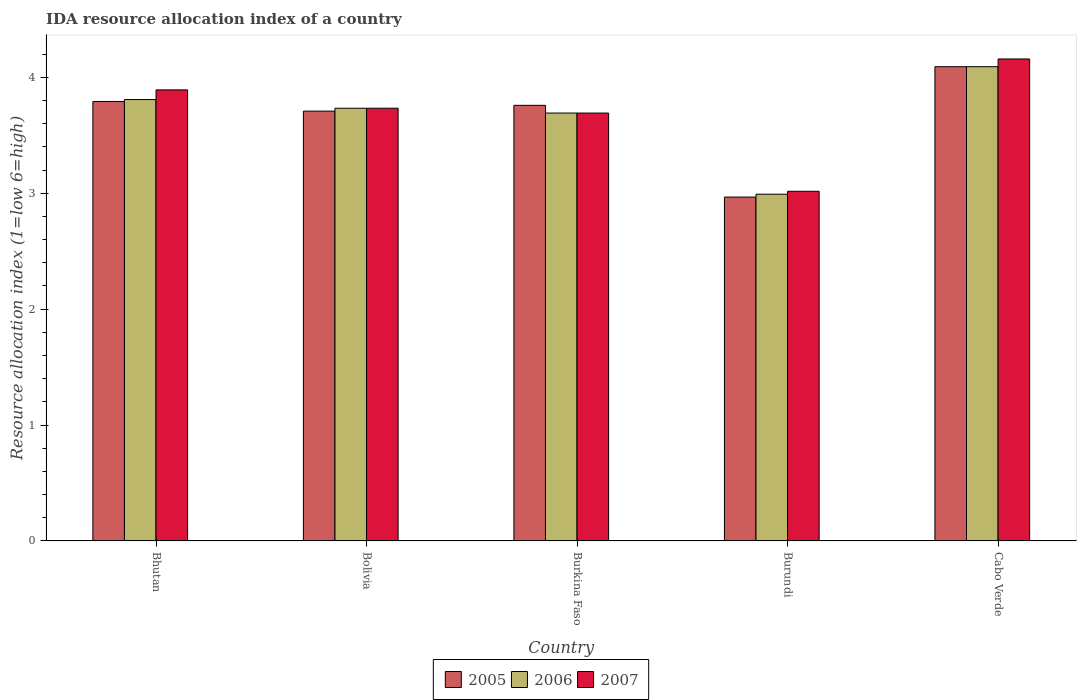How many groups of bars are there?
Provide a succinct answer. 5. Are the number of bars per tick equal to the number of legend labels?
Ensure brevity in your answer.  Yes. Are the number of bars on each tick of the X-axis equal?
Offer a terse response. Yes. How many bars are there on the 1st tick from the left?
Your response must be concise. 3. What is the label of the 1st group of bars from the left?
Your response must be concise. Bhutan. In how many cases, is the number of bars for a given country not equal to the number of legend labels?
Offer a very short reply. 0. What is the IDA resource allocation index in 2005 in Burundi?
Keep it short and to the point. 2.97. Across all countries, what is the maximum IDA resource allocation index in 2007?
Your response must be concise. 4.16. Across all countries, what is the minimum IDA resource allocation index in 2005?
Your answer should be very brief. 2.97. In which country was the IDA resource allocation index in 2006 maximum?
Your response must be concise. Cabo Verde. In which country was the IDA resource allocation index in 2005 minimum?
Offer a very short reply. Burundi. What is the total IDA resource allocation index in 2005 in the graph?
Your answer should be very brief. 18.32. What is the difference between the IDA resource allocation index in 2006 in Bhutan and that in Cabo Verde?
Offer a terse response. -0.28. What is the difference between the IDA resource allocation index in 2006 in Burkina Faso and the IDA resource allocation index in 2007 in Burundi?
Your response must be concise. 0.67. What is the average IDA resource allocation index in 2005 per country?
Offer a very short reply. 3.66. What is the difference between the IDA resource allocation index of/in 2007 and IDA resource allocation index of/in 2006 in Burkina Faso?
Provide a short and direct response. 0. In how many countries, is the IDA resource allocation index in 2007 greater than 3?
Keep it short and to the point. 5. What is the ratio of the IDA resource allocation index in 2005 in Burundi to that in Cabo Verde?
Give a very brief answer. 0.73. Is the difference between the IDA resource allocation index in 2007 in Bhutan and Burkina Faso greater than the difference between the IDA resource allocation index in 2006 in Bhutan and Burkina Faso?
Your answer should be very brief. Yes. What is the difference between the highest and the second highest IDA resource allocation index in 2006?
Keep it short and to the point. -0.08. What is the difference between the highest and the lowest IDA resource allocation index in 2005?
Ensure brevity in your answer.  1.12. In how many countries, is the IDA resource allocation index in 2007 greater than the average IDA resource allocation index in 2007 taken over all countries?
Ensure brevity in your answer.  3. Is the sum of the IDA resource allocation index in 2005 in Bhutan and Bolivia greater than the maximum IDA resource allocation index in 2006 across all countries?
Offer a terse response. Yes. What does the 3rd bar from the left in Burundi represents?
Keep it short and to the point. 2007. What does the 2nd bar from the right in Burundi represents?
Provide a succinct answer. 2006. Is it the case that in every country, the sum of the IDA resource allocation index in 2006 and IDA resource allocation index in 2005 is greater than the IDA resource allocation index in 2007?
Give a very brief answer. Yes. Are all the bars in the graph horizontal?
Provide a succinct answer. No. What is the difference between two consecutive major ticks on the Y-axis?
Your response must be concise. 1. Does the graph contain any zero values?
Make the answer very short. No. What is the title of the graph?
Provide a short and direct response. IDA resource allocation index of a country. Does "2012" appear as one of the legend labels in the graph?
Keep it short and to the point. No. What is the label or title of the Y-axis?
Offer a terse response. Resource allocation index (1=low 6=high). What is the Resource allocation index (1=low 6=high) of 2005 in Bhutan?
Provide a succinct answer. 3.79. What is the Resource allocation index (1=low 6=high) in 2006 in Bhutan?
Offer a very short reply. 3.81. What is the Resource allocation index (1=low 6=high) of 2007 in Bhutan?
Keep it short and to the point. 3.89. What is the Resource allocation index (1=low 6=high) of 2005 in Bolivia?
Provide a short and direct response. 3.71. What is the Resource allocation index (1=low 6=high) of 2006 in Bolivia?
Keep it short and to the point. 3.73. What is the Resource allocation index (1=low 6=high) in 2007 in Bolivia?
Your answer should be very brief. 3.73. What is the Resource allocation index (1=low 6=high) of 2005 in Burkina Faso?
Your answer should be very brief. 3.76. What is the Resource allocation index (1=low 6=high) in 2006 in Burkina Faso?
Offer a terse response. 3.69. What is the Resource allocation index (1=low 6=high) of 2007 in Burkina Faso?
Offer a terse response. 3.69. What is the Resource allocation index (1=low 6=high) of 2005 in Burundi?
Make the answer very short. 2.97. What is the Resource allocation index (1=low 6=high) of 2006 in Burundi?
Keep it short and to the point. 2.99. What is the Resource allocation index (1=low 6=high) of 2007 in Burundi?
Offer a very short reply. 3.02. What is the Resource allocation index (1=low 6=high) of 2005 in Cabo Verde?
Offer a terse response. 4.09. What is the Resource allocation index (1=low 6=high) in 2006 in Cabo Verde?
Your answer should be very brief. 4.09. What is the Resource allocation index (1=low 6=high) in 2007 in Cabo Verde?
Your answer should be compact. 4.16. Across all countries, what is the maximum Resource allocation index (1=low 6=high) of 2005?
Offer a terse response. 4.09. Across all countries, what is the maximum Resource allocation index (1=low 6=high) of 2006?
Ensure brevity in your answer.  4.09. Across all countries, what is the maximum Resource allocation index (1=low 6=high) in 2007?
Ensure brevity in your answer.  4.16. Across all countries, what is the minimum Resource allocation index (1=low 6=high) in 2005?
Make the answer very short. 2.97. Across all countries, what is the minimum Resource allocation index (1=low 6=high) in 2006?
Offer a very short reply. 2.99. Across all countries, what is the minimum Resource allocation index (1=low 6=high) of 2007?
Your response must be concise. 3.02. What is the total Resource allocation index (1=low 6=high) in 2005 in the graph?
Your answer should be very brief. 18.32. What is the total Resource allocation index (1=low 6=high) of 2006 in the graph?
Your response must be concise. 18.32. What is the total Resource allocation index (1=low 6=high) in 2007 in the graph?
Your answer should be compact. 18.49. What is the difference between the Resource allocation index (1=low 6=high) in 2005 in Bhutan and that in Bolivia?
Offer a very short reply. 0.08. What is the difference between the Resource allocation index (1=low 6=high) in 2006 in Bhutan and that in Bolivia?
Make the answer very short. 0.07. What is the difference between the Resource allocation index (1=low 6=high) of 2007 in Bhutan and that in Bolivia?
Make the answer very short. 0.16. What is the difference between the Resource allocation index (1=low 6=high) of 2006 in Bhutan and that in Burkina Faso?
Provide a short and direct response. 0.12. What is the difference between the Resource allocation index (1=low 6=high) of 2005 in Bhutan and that in Burundi?
Give a very brief answer. 0.82. What is the difference between the Resource allocation index (1=low 6=high) of 2006 in Bhutan and that in Burundi?
Keep it short and to the point. 0.82. What is the difference between the Resource allocation index (1=low 6=high) in 2007 in Bhutan and that in Burundi?
Ensure brevity in your answer.  0.88. What is the difference between the Resource allocation index (1=low 6=high) in 2005 in Bhutan and that in Cabo Verde?
Your answer should be very brief. -0.3. What is the difference between the Resource allocation index (1=low 6=high) in 2006 in Bhutan and that in Cabo Verde?
Give a very brief answer. -0.28. What is the difference between the Resource allocation index (1=low 6=high) in 2007 in Bhutan and that in Cabo Verde?
Offer a terse response. -0.27. What is the difference between the Resource allocation index (1=low 6=high) of 2006 in Bolivia and that in Burkina Faso?
Make the answer very short. 0.04. What is the difference between the Resource allocation index (1=low 6=high) of 2007 in Bolivia and that in Burkina Faso?
Make the answer very short. 0.04. What is the difference between the Resource allocation index (1=low 6=high) in 2005 in Bolivia and that in Burundi?
Ensure brevity in your answer.  0.74. What is the difference between the Resource allocation index (1=low 6=high) in 2006 in Bolivia and that in Burundi?
Offer a terse response. 0.74. What is the difference between the Resource allocation index (1=low 6=high) of 2007 in Bolivia and that in Burundi?
Offer a very short reply. 0.72. What is the difference between the Resource allocation index (1=low 6=high) in 2005 in Bolivia and that in Cabo Verde?
Ensure brevity in your answer.  -0.38. What is the difference between the Resource allocation index (1=low 6=high) in 2006 in Bolivia and that in Cabo Verde?
Keep it short and to the point. -0.36. What is the difference between the Resource allocation index (1=low 6=high) of 2007 in Bolivia and that in Cabo Verde?
Your response must be concise. -0.42. What is the difference between the Resource allocation index (1=low 6=high) of 2005 in Burkina Faso and that in Burundi?
Your answer should be very brief. 0.79. What is the difference between the Resource allocation index (1=low 6=high) of 2007 in Burkina Faso and that in Burundi?
Provide a succinct answer. 0.68. What is the difference between the Resource allocation index (1=low 6=high) in 2006 in Burkina Faso and that in Cabo Verde?
Your answer should be compact. -0.4. What is the difference between the Resource allocation index (1=low 6=high) in 2007 in Burkina Faso and that in Cabo Verde?
Keep it short and to the point. -0.47. What is the difference between the Resource allocation index (1=low 6=high) in 2005 in Burundi and that in Cabo Verde?
Provide a succinct answer. -1.12. What is the difference between the Resource allocation index (1=low 6=high) in 2006 in Burundi and that in Cabo Verde?
Offer a terse response. -1.1. What is the difference between the Resource allocation index (1=low 6=high) in 2007 in Burundi and that in Cabo Verde?
Your response must be concise. -1.14. What is the difference between the Resource allocation index (1=low 6=high) of 2005 in Bhutan and the Resource allocation index (1=low 6=high) of 2006 in Bolivia?
Ensure brevity in your answer.  0.06. What is the difference between the Resource allocation index (1=low 6=high) in 2005 in Bhutan and the Resource allocation index (1=low 6=high) in 2007 in Bolivia?
Provide a succinct answer. 0.06. What is the difference between the Resource allocation index (1=low 6=high) of 2006 in Bhutan and the Resource allocation index (1=low 6=high) of 2007 in Bolivia?
Offer a terse response. 0.07. What is the difference between the Resource allocation index (1=low 6=high) in 2005 in Bhutan and the Resource allocation index (1=low 6=high) in 2006 in Burkina Faso?
Make the answer very short. 0.1. What is the difference between the Resource allocation index (1=low 6=high) in 2005 in Bhutan and the Resource allocation index (1=low 6=high) in 2007 in Burkina Faso?
Offer a very short reply. 0.1. What is the difference between the Resource allocation index (1=low 6=high) in 2006 in Bhutan and the Resource allocation index (1=low 6=high) in 2007 in Burkina Faso?
Make the answer very short. 0.12. What is the difference between the Resource allocation index (1=low 6=high) in 2005 in Bhutan and the Resource allocation index (1=low 6=high) in 2006 in Burundi?
Your answer should be compact. 0.8. What is the difference between the Resource allocation index (1=low 6=high) in 2005 in Bhutan and the Resource allocation index (1=low 6=high) in 2007 in Burundi?
Provide a short and direct response. 0.78. What is the difference between the Resource allocation index (1=low 6=high) of 2006 in Bhutan and the Resource allocation index (1=low 6=high) of 2007 in Burundi?
Your response must be concise. 0.79. What is the difference between the Resource allocation index (1=low 6=high) in 2005 in Bhutan and the Resource allocation index (1=low 6=high) in 2007 in Cabo Verde?
Keep it short and to the point. -0.37. What is the difference between the Resource allocation index (1=low 6=high) in 2006 in Bhutan and the Resource allocation index (1=low 6=high) in 2007 in Cabo Verde?
Your answer should be very brief. -0.35. What is the difference between the Resource allocation index (1=low 6=high) of 2005 in Bolivia and the Resource allocation index (1=low 6=high) of 2006 in Burkina Faso?
Offer a very short reply. 0.02. What is the difference between the Resource allocation index (1=low 6=high) in 2005 in Bolivia and the Resource allocation index (1=low 6=high) in 2007 in Burkina Faso?
Offer a very short reply. 0.02. What is the difference between the Resource allocation index (1=low 6=high) of 2006 in Bolivia and the Resource allocation index (1=low 6=high) of 2007 in Burkina Faso?
Keep it short and to the point. 0.04. What is the difference between the Resource allocation index (1=low 6=high) of 2005 in Bolivia and the Resource allocation index (1=low 6=high) of 2006 in Burundi?
Offer a terse response. 0.72. What is the difference between the Resource allocation index (1=low 6=high) in 2005 in Bolivia and the Resource allocation index (1=low 6=high) in 2007 in Burundi?
Your response must be concise. 0.69. What is the difference between the Resource allocation index (1=low 6=high) of 2006 in Bolivia and the Resource allocation index (1=low 6=high) of 2007 in Burundi?
Give a very brief answer. 0.72. What is the difference between the Resource allocation index (1=low 6=high) of 2005 in Bolivia and the Resource allocation index (1=low 6=high) of 2006 in Cabo Verde?
Ensure brevity in your answer.  -0.38. What is the difference between the Resource allocation index (1=low 6=high) in 2005 in Bolivia and the Resource allocation index (1=low 6=high) in 2007 in Cabo Verde?
Give a very brief answer. -0.45. What is the difference between the Resource allocation index (1=low 6=high) in 2006 in Bolivia and the Resource allocation index (1=low 6=high) in 2007 in Cabo Verde?
Your answer should be compact. -0.42. What is the difference between the Resource allocation index (1=low 6=high) in 2005 in Burkina Faso and the Resource allocation index (1=low 6=high) in 2006 in Burundi?
Offer a very short reply. 0.77. What is the difference between the Resource allocation index (1=low 6=high) in 2005 in Burkina Faso and the Resource allocation index (1=low 6=high) in 2007 in Burundi?
Provide a succinct answer. 0.74. What is the difference between the Resource allocation index (1=low 6=high) in 2006 in Burkina Faso and the Resource allocation index (1=low 6=high) in 2007 in Burundi?
Keep it short and to the point. 0.68. What is the difference between the Resource allocation index (1=low 6=high) in 2005 in Burkina Faso and the Resource allocation index (1=low 6=high) in 2006 in Cabo Verde?
Offer a very short reply. -0.33. What is the difference between the Resource allocation index (1=low 6=high) in 2006 in Burkina Faso and the Resource allocation index (1=low 6=high) in 2007 in Cabo Verde?
Provide a succinct answer. -0.47. What is the difference between the Resource allocation index (1=low 6=high) in 2005 in Burundi and the Resource allocation index (1=low 6=high) in 2006 in Cabo Verde?
Offer a terse response. -1.12. What is the difference between the Resource allocation index (1=low 6=high) in 2005 in Burundi and the Resource allocation index (1=low 6=high) in 2007 in Cabo Verde?
Give a very brief answer. -1.19. What is the difference between the Resource allocation index (1=low 6=high) in 2006 in Burundi and the Resource allocation index (1=low 6=high) in 2007 in Cabo Verde?
Your answer should be compact. -1.17. What is the average Resource allocation index (1=low 6=high) of 2005 per country?
Keep it short and to the point. 3.66. What is the average Resource allocation index (1=low 6=high) of 2006 per country?
Make the answer very short. 3.66. What is the average Resource allocation index (1=low 6=high) of 2007 per country?
Provide a short and direct response. 3.7. What is the difference between the Resource allocation index (1=low 6=high) of 2005 and Resource allocation index (1=low 6=high) of 2006 in Bhutan?
Offer a very short reply. -0.02. What is the difference between the Resource allocation index (1=low 6=high) in 2006 and Resource allocation index (1=low 6=high) in 2007 in Bhutan?
Keep it short and to the point. -0.08. What is the difference between the Resource allocation index (1=low 6=high) in 2005 and Resource allocation index (1=low 6=high) in 2006 in Bolivia?
Your response must be concise. -0.03. What is the difference between the Resource allocation index (1=low 6=high) in 2005 and Resource allocation index (1=low 6=high) in 2007 in Bolivia?
Offer a very short reply. -0.03. What is the difference between the Resource allocation index (1=low 6=high) of 2006 and Resource allocation index (1=low 6=high) of 2007 in Bolivia?
Your answer should be very brief. 0. What is the difference between the Resource allocation index (1=low 6=high) of 2005 and Resource allocation index (1=low 6=high) of 2006 in Burkina Faso?
Give a very brief answer. 0.07. What is the difference between the Resource allocation index (1=low 6=high) in 2005 and Resource allocation index (1=low 6=high) in 2007 in Burkina Faso?
Your answer should be compact. 0.07. What is the difference between the Resource allocation index (1=low 6=high) in 2006 and Resource allocation index (1=low 6=high) in 2007 in Burkina Faso?
Your response must be concise. 0. What is the difference between the Resource allocation index (1=low 6=high) of 2005 and Resource allocation index (1=low 6=high) of 2006 in Burundi?
Make the answer very short. -0.03. What is the difference between the Resource allocation index (1=low 6=high) in 2005 and Resource allocation index (1=low 6=high) in 2007 in Burundi?
Offer a very short reply. -0.05. What is the difference between the Resource allocation index (1=low 6=high) in 2006 and Resource allocation index (1=low 6=high) in 2007 in Burundi?
Offer a terse response. -0.03. What is the difference between the Resource allocation index (1=low 6=high) in 2005 and Resource allocation index (1=low 6=high) in 2006 in Cabo Verde?
Make the answer very short. 0. What is the difference between the Resource allocation index (1=low 6=high) of 2005 and Resource allocation index (1=low 6=high) of 2007 in Cabo Verde?
Make the answer very short. -0.07. What is the difference between the Resource allocation index (1=low 6=high) of 2006 and Resource allocation index (1=low 6=high) of 2007 in Cabo Verde?
Offer a terse response. -0.07. What is the ratio of the Resource allocation index (1=low 6=high) of 2005 in Bhutan to that in Bolivia?
Offer a terse response. 1.02. What is the ratio of the Resource allocation index (1=low 6=high) of 2006 in Bhutan to that in Bolivia?
Offer a very short reply. 1.02. What is the ratio of the Resource allocation index (1=low 6=high) of 2007 in Bhutan to that in Bolivia?
Your response must be concise. 1.04. What is the ratio of the Resource allocation index (1=low 6=high) of 2005 in Bhutan to that in Burkina Faso?
Provide a succinct answer. 1.01. What is the ratio of the Resource allocation index (1=low 6=high) in 2006 in Bhutan to that in Burkina Faso?
Offer a very short reply. 1.03. What is the ratio of the Resource allocation index (1=low 6=high) of 2007 in Bhutan to that in Burkina Faso?
Make the answer very short. 1.05. What is the ratio of the Resource allocation index (1=low 6=high) of 2005 in Bhutan to that in Burundi?
Ensure brevity in your answer.  1.28. What is the ratio of the Resource allocation index (1=low 6=high) of 2006 in Bhutan to that in Burundi?
Your response must be concise. 1.27. What is the ratio of the Resource allocation index (1=low 6=high) in 2007 in Bhutan to that in Burundi?
Offer a very short reply. 1.29. What is the ratio of the Resource allocation index (1=low 6=high) of 2005 in Bhutan to that in Cabo Verde?
Make the answer very short. 0.93. What is the ratio of the Resource allocation index (1=low 6=high) of 2006 in Bhutan to that in Cabo Verde?
Make the answer very short. 0.93. What is the ratio of the Resource allocation index (1=low 6=high) in 2007 in Bhutan to that in Cabo Verde?
Your answer should be very brief. 0.94. What is the ratio of the Resource allocation index (1=low 6=high) in 2005 in Bolivia to that in Burkina Faso?
Offer a very short reply. 0.99. What is the ratio of the Resource allocation index (1=low 6=high) in 2006 in Bolivia to that in Burkina Faso?
Offer a very short reply. 1.01. What is the ratio of the Resource allocation index (1=low 6=high) in 2007 in Bolivia to that in Burkina Faso?
Offer a terse response. 1.01. What is the ratio of the Resource allocation index (1=low 6=high) in 2006 in Bolivia to that in Burundi?
Make the answer very short. 1.25. What is the ratio of the Resource allocation index (1=low 6=high) in 2007 in Bolivia to that in Burundi?
Provide a succinct answer. 1.24. What is the ratio of the Resource allocation index (1=low 6=high) of 2005 in Bolivia to that in Cabo Verde?
Offer a very short reply. 0.91. What is the ratio of the Resource allocation index (1=low 6=high) in 2006 in Bolivia to that in Cabo Verde?
Ensure brevity in your answer.  0.91. What is the ratio of the Resource allocation index (1=low 6=high) in 2007 in Bolivia to that in Cabo Verde?
Your answer should be compact. 0.9. What is the ratio of the Resource allocation index (1=low 6=high) of 2005 in Burkina Faso to that in Burundi?
Offer a terse response. 1.27. What is the ratio of the Resource allocation index (1=low 6=high) of 2006 in Burkina Faso to that in Burundi?
Your answer should be compact. 1.23. What is the ratio of the Resource allocation index (1=low 6=high) of 2007 in Burkina Faso to that in Burundi?
Ensure brevity in your answer.  1.22. What is the ratio of the Resource allocation index (1=low 6=high) of 2005 in Burkina Faso to that in Cabo Verde?
Your answer should be compact. 0.92. What is the ratio of the Resource allocation index (1=low 6=high) of 2006 in Burkina Faso to that in Cabo Verde?
Offer a very short reply. 0.9. What is the ratio of the Resource allocation index (1=low 6=high) in 2007 in Burkina Faso to that in Cabo Verde?
Ensure brevity in your answer.  0.89. What is the ratio of the Resource allocation index (1=low 6=high) in 2005 in Burundi to that in Cabo Verde?
Give a very brief answer. 0.73. What is the ratio of the Resource allocation index (1=low 6=high) in 2006 in Burundi to that in Cabo Verde?
Offer a terse response. 0.73. What is the ratio of the Resource allocation index (1=low 6=high) of 2007 in Burundi to that in Cabo Verde?
Provide a short and direct response. 0.73. What is the difference between the highest and the second highest Resource allocation index (1=low 6=high) in 2005?
Make the answer very short. 0.3. What is the difference between the highest and the second highest Resource allocation index (1=low 6=high) of 2006?
Ensure brevity in your answer.  0.28. What is the difference between the highest and the second highest Resource allocation index (1=low 6=high) of 2007?
Your answer should be compact. 0.27. What is the difference between the highest and the lowest Resource allocation index (1=low 6=high) in 2005?
Provide a succinct answer. 1.12. What is the difference between the highest and the lowest Resource allocation index (1=low 6=high) in 2006?
Give a very brief answer. 1.1. What is the difference between the highest and the lowest Resource allocation index (1=low 6=high) in 2007?
Your response must be concise. 1.14. 